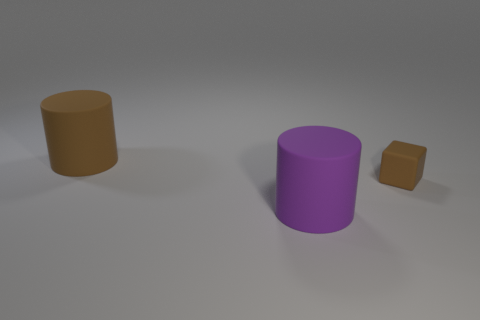The object that is behind the big purple matte cylinder and left of the tiny object is made of what material? The object in question appears to be a simple 3D model and does not have a texture that would indicate a specific, real-world material. However, since it resembles common objects generally made of plastic or wood, one might infer that the simulated material could be either of the two, but it's simply a part of the rendered image with no actual material properties. 